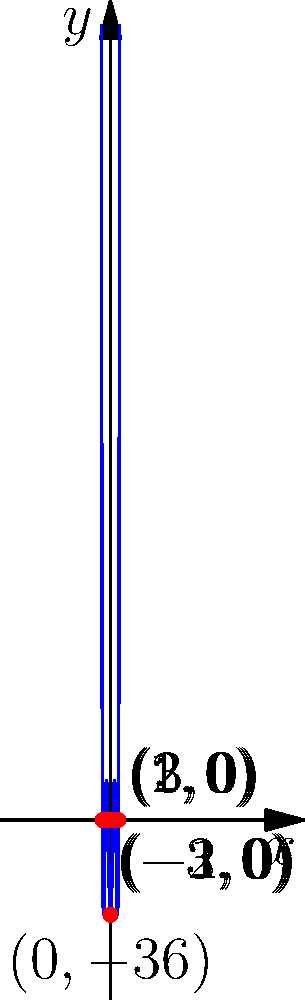The polynomial function $f(x) = (x^2-1)(x^2-4)(x^2-9)$ represents the Star of David. How many real roots does this function have, and what is the significance of these roots in relation to the Star of David symbol? To solve this problem, let's follow these steps:

1) First, let's factor the polynomial:
   $f(x) = (x^2-1)(x^2-4)(x^2-9)$
   $= (x-1)(x+1)(x-2)(x+2)(x-3)(x+3)$

2) The roots of the polynomial are the values of x that make $f(x) = 0$. These occur when any of the factors equal zero.

3) Setting each factor to zero:
   $x-1 = 0$, $x = 1$
   $x+1 = 0$, $x = -1$
   $x-2 = 0$, $x = 2$
   $x+2 = 0$, $x = -2$
   $x-3 = 0$, $x = 3$
   $x+3 = 0$, $x = -3$

4) Therefore, the roots are: $\pm1, \pm2, \pm3$

5) There are 6 real roots in total.

6) The significance of these roots in relation to the Star of David:
   - The Star of David is a six-pointed star formed by two overlapping equilateral triangles.
   - The 6 roots correspond to the 6 points of the star.
   - The symmetry of the roots (positive and negative pairs) reflects the symmetry of the Star of David.
   - The three different magnitudes (1, 2, and 3) could represent the three lines that form each triangle in the star.

7) The y-intercept at (0, -36) represents the center of the star where all lines intersect.

This polynomial representation elegantly captures the geometric properties of the Star of David, a symbol of great importance in Jewish culture and identity.
Answer: 6 roots; correspond to 6 points of Star of David 